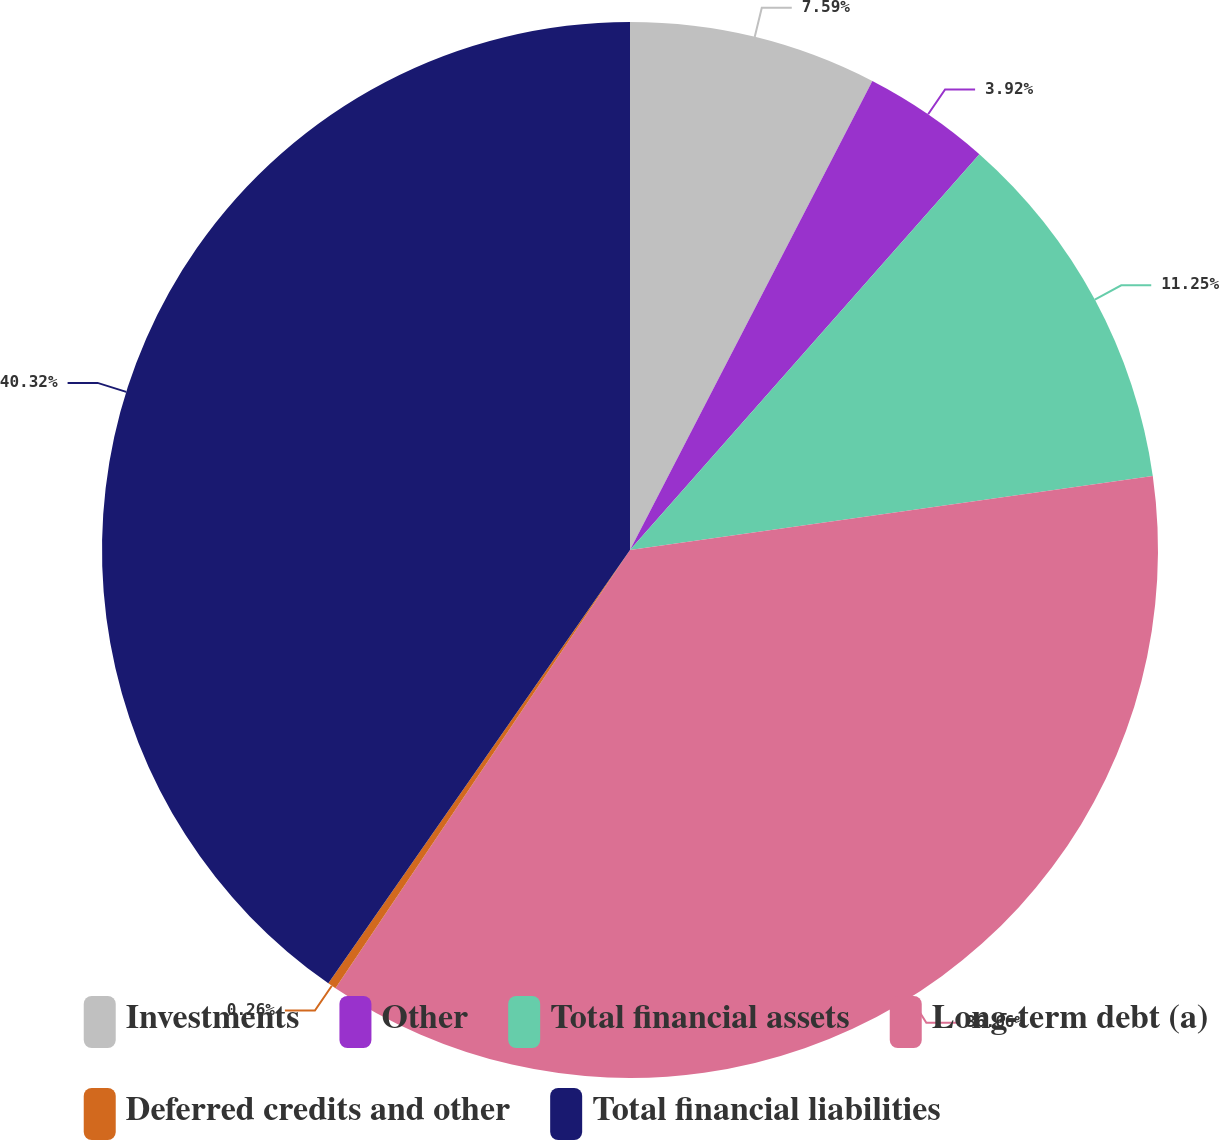Convert chart. <chart><loc_0><loc_0><loc_500><loc_500><pie_chart><fcel>Investments<fcel>Other<fcel>Total financial assets<fcel>Long-term debt (a)<fcel>Deferred credits and other<fcel>Total financial liabilities<nl><fcel>7.59%<fcel>3.92%<fcel>11.25%<fcel>36.66%<fcel>0.26%<fcel>40.32%<nl></chart> 